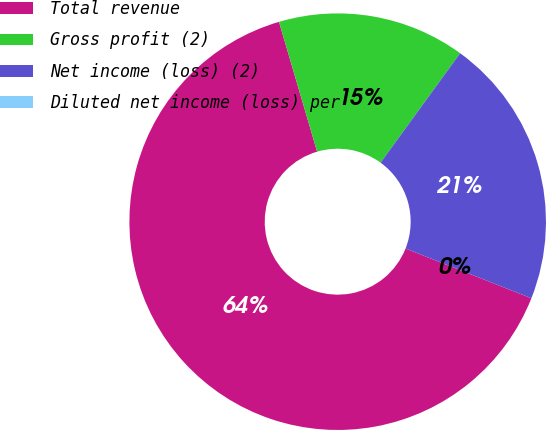Convert chart. <chart><loc_0><loc_0><loc_500><loc_500><pie_chart><fcel>Total revenue<fcel>Gross profit (2)<fcel>Net income (loss) (2)<fcel>Diluted net income (loss) per<nl><fcel>64.46%<fcel>14.55%<fcel>20.99%<fcel>0.0%<nl></chart> 